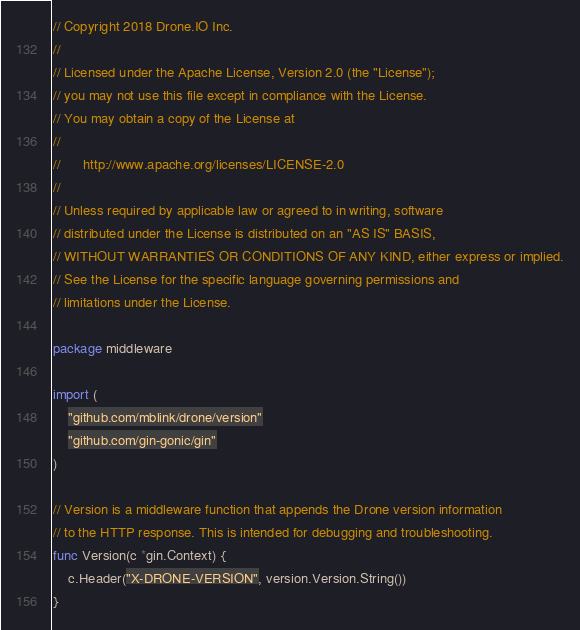Convert code to text. <code><loc_0><loc_0><loc_500><loc_500><_Go_>// Copyright 2018 Drone.IO Inc.
//
// Licensed under the Apache License, Version 2.0 (the "License");
// you may not use this file except in compliance with the License.
// You may obtain a copy of the License at
//
//      http://www.apache.org/licenses/LICENSE-2.0
//
// Unless required by applicable law or agreed to in writing, software
// distributed under the License is distributed on an "AS IS" BASIS,
// WITHOUT WARRANTIES OR CONDITIONS OF ANY KIND, either express or implied.
// See the License for the specific language governing permissions and
// limitations under the License.

package middleware

import (
	"github.com/mblink/drone/version"
	"github.com/gin-gonic/gin"
)

// Version is a middleware function that appends the Drone version information
// to the HTTP response. This is intended for debugging and troubleshooting.
func Version(c *gin.Context) {
	c.Header("X-DRONE-VERSION", version.Version.String())
}
</code> 